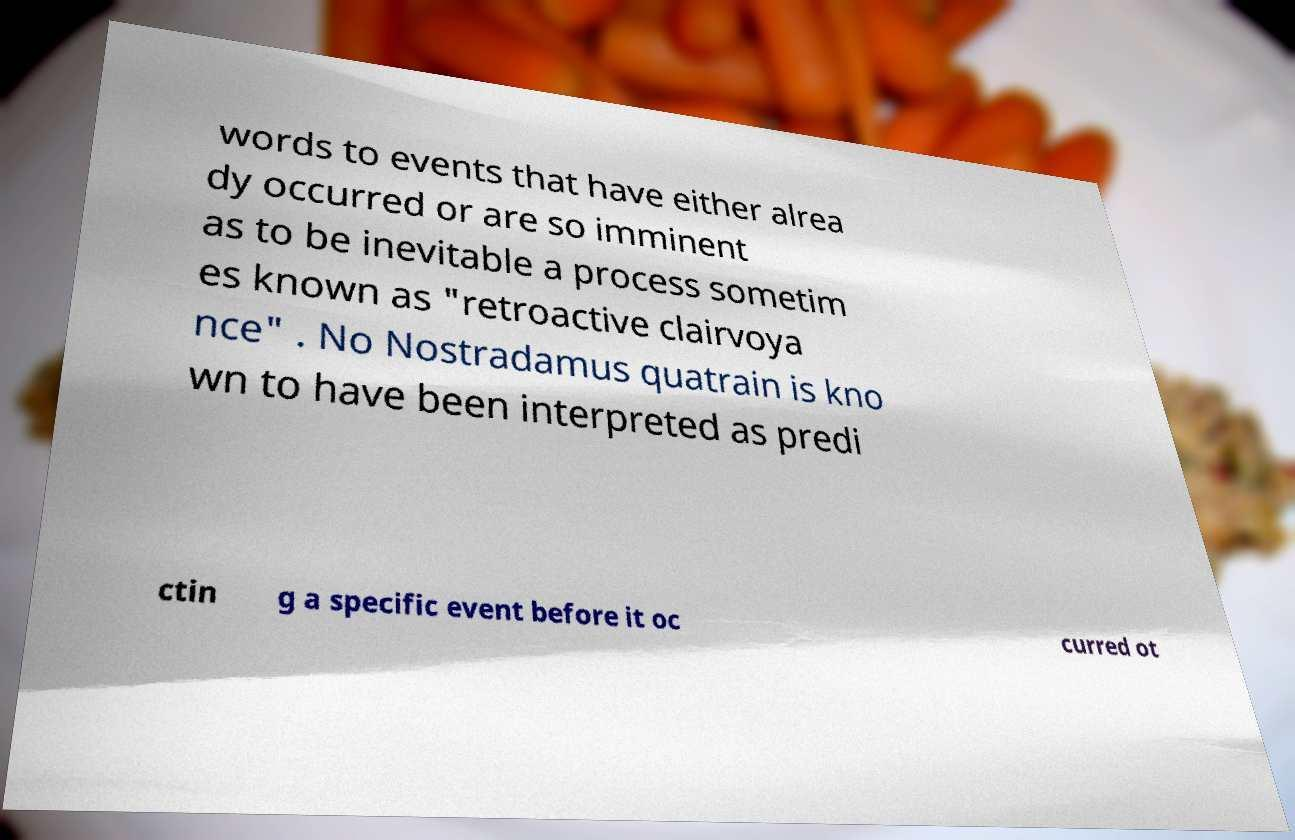Can you accurately transcribe the text from the provided image for me? words to events that have either alrea dy occurred or are so imminent as to be inevitable a process sometim es known as "retroactive clairvoya nce" . No Nostradamus quatrain is kno wn to have been interpreted as predi ctin g a specific event before it oc curred ot 